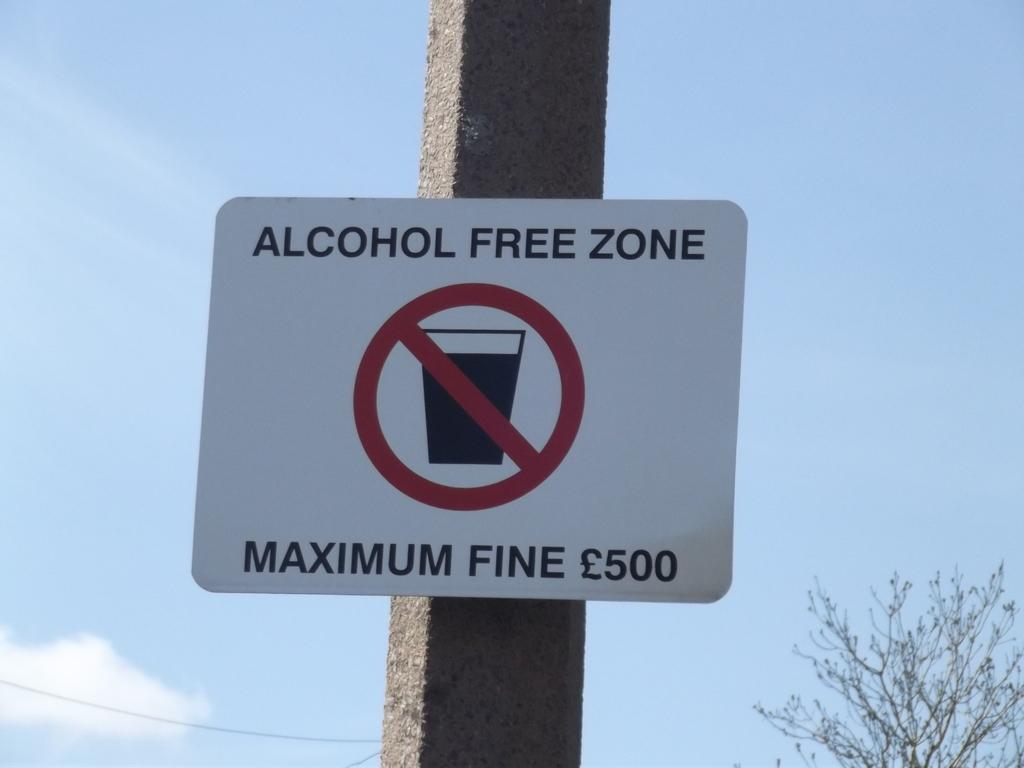<image>
Create a compact narrative representing the image presented. A sign on a pole that says Alcohol Free Zone. 